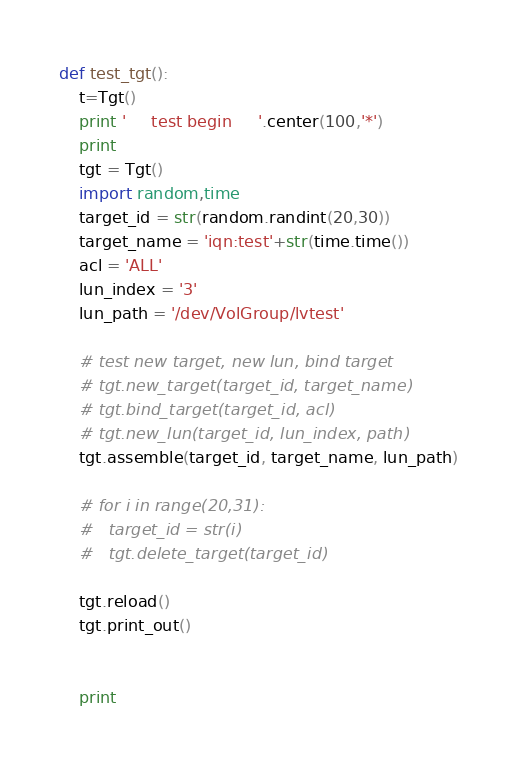Convert code to text. <code><loc_0><loc_0><loc_500><loc_500><_Python_>def test_tgt():
	t=Tgt()
	print '     test begin     '.center(100,'*')
	print 
	tgt = Tgt()
	import random,time
	target_id = str(random.randint(20,30))
	target_name = 'iqn:test'+str(time.time())
	acl = 'ALL'
	lun_index = '3'
	lun_path = '/dev/VolGroup/lvtest'

	# test new target, new lun, bind target
	# tgt.new_target(target_id, target_name)
	# tgt.bind_target(target_id, acl)
	# tgt.new_lun(target_id, lun_index, path)
	tgt.assemble(target_id, target_name, lun_path)

	# for i in range(20,31):
	# 	target_id = str(i)
	# 	tgt.delete_target(target_id)
	
	tgt.reload()
	tgt.print_out()
	

	print </code> 